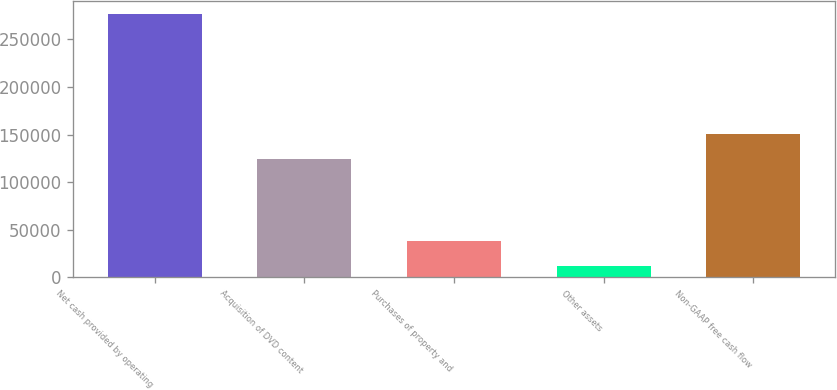<chart> <loc_0><loc_0><loc_500><loc_500><bar_chart><fcel>Net cash provided by operating<fcel>Acquisition of DVD content<fcel>Purchases of property and<fcel>Other assets<fcel>Non-GAAP free cash flow<nl><fcel>276401<fcel>123901<fcel>38749.7<fcel>12344<fcel>150307<nl></chart> 